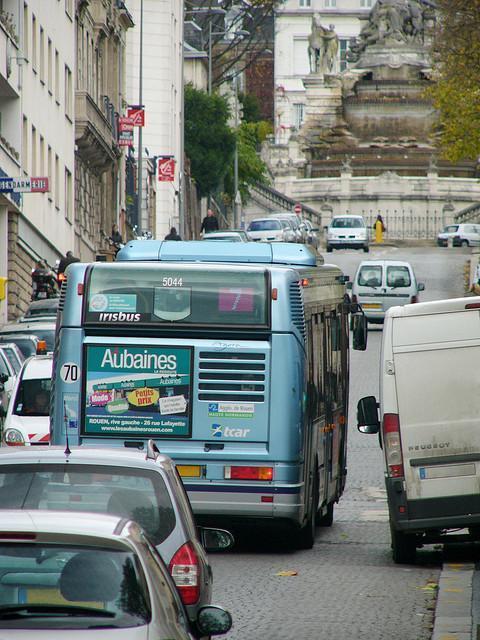How many cars are visible?
Give a very brief answer. 6. 